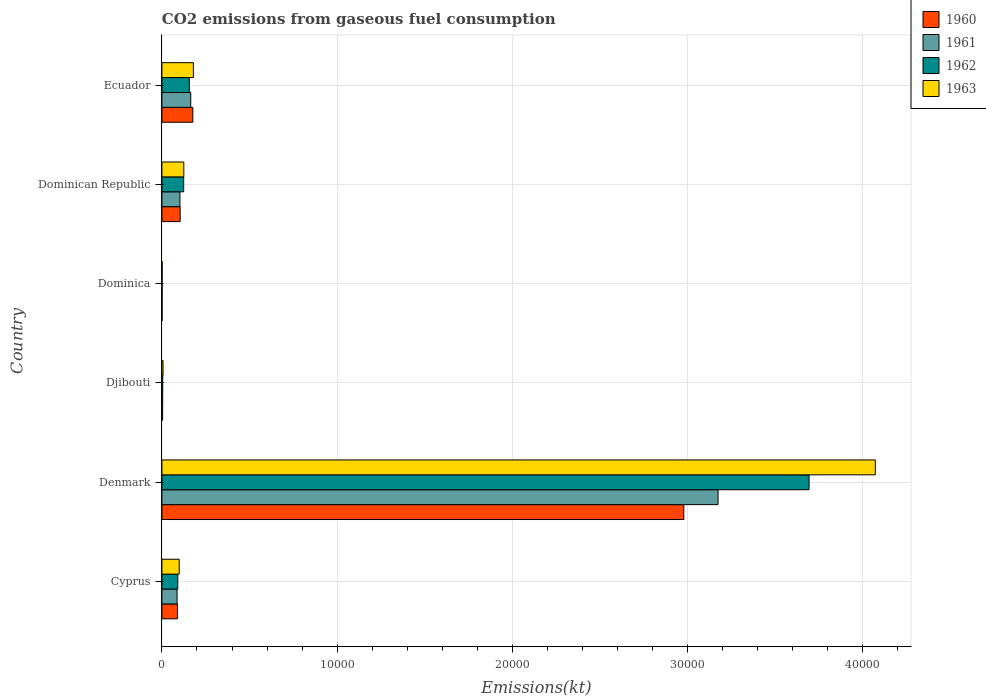How many different coloured bars are there?
Offer a very short reply. 4. How many groups of bars are there?
Keep it short and to the point. 6. Are the number of bars per tick equal to the number of legend labels?
Your response must be concise. Yes. How many bars are there on the 2nd tick from the top?
Give a very brief answer. 4. What is the label of the 4th group of bars from the top?
Keep it short and to the point. Djibouti. In how many cases, is the number of bars for a given country not equal to the number of legend labels?
Give a very brief answer. 0. What is the amount of CO2 emitted in 1961 in Denmark?
Give a very brief answer. 3.17e+04. Across all countries, what is the maximum amount of CO2 emitted in 1961?
Your answer should be very brief. 3.17e+04. Across all countries, what is the minimum amount of CO2 emitted in 1960?
Make the answer very short. 11. In which country was the amount of CO2 emitted in 1963 minimum?
Keep it short and to the point. Dominica. What is the total amount of CO2 emitted in 1961 in the graph?
Give a very brief answer. 3.53e+04. What is the difference between the amount of CO2 emitted in 1963 in Djibouti and that in Dominican Republic?
Give a very brief answer. -1184.44. What is the difference between the amount of CO2 emitted in 1960 in Cyprus and the amount of CO2 emitted in 1963 in Denmark?
Make the answer very short. -3.98e+04. What is the average amount of CO2 emitted in 1960 per country?
Give a very brief answer. 5587.29. What is the difference between the amount of CO2 emitted in 1962 and amount of CO2 emitted in 1961 in Dominica?
Provide a succinct answer. 0. What is the ratio of the amount of CO2 emitted in 1962 in Denmark to that in Ecuador?
Give a very brief answer. 23.58. Is the amount of CO2 emitted in 1962 in Cyprus less than that in Denmark?
Your answer should be compact. Yes. What is the difference between the highest and the second highest amount of CO2 emitted in 1962?
Provide a succinct answer. 3.54e+04. What is the difference between the highest and the lowest amount of CO2 emitted in 1962?
Give a very brief answer. 3.69e+04. In how many countries, is the amount of CO2 emitted in 1961 greater than the average amount of CO2 emitted in 1961 taken over all countries?
Provide a short and direct response. 1. Is it the case that in every country, the sum of the amount of CO2 emitted in 1960 and amount of CO2 emitted in 1961 is greater than the amount of CO2 emitted in 1963?
Give a very brief answer. Yes. How many bars are there?
Provide a short and direct response. 24. Are the values on the major ticks of X-axis written in scientific E-notation?
Keep it short and to the point. No. How many legend labels are there?
Give a very brief answer. 4. How are the legend labels stacked?
Offer a terse response. Vertical. What is the title of the graph?
Ensure brevity in your answer.  CO2 emissions from gaseous fuel consumption. Does "1998" appear as one of the legend labels in the graph?
Offer a terse response. No. What is the label or title of the X-axis?
Provide a short and direct response. Emissions(kt). What is the Emissions(kt) of 1960 in Cyprus?
Your answer should be compact. 887.41. What is the Emissions(kt) of 1961 in Cyprus?
Offer a terse response. 865.41. What is the Emissions(kt) of 1962 in Cyprus?
Provide a succinct answer. 905.75. What is the Emissions(kt) of 1963 in Cyprus?
Provide a succinct answer. 986.42. What is the Emissions(kt) of 1960 in Denmark?
Make the answer very short. 2.98e+04. What is the Emissions(kt) in 1961 in Denmark?
Provide a succinct answer. 3.17e+04. What is the Emissions(kt) in 1962 in Denmark?
Make the answer very short. 3.69e+04. What is the Emissions(kt) in 1963 in Denmark?
Make the answer very short. 4.07e+04. What is the Emissions(kt) of 1960 in Djibouti?
Give a very brief answer. 40.34. What is the Emissions(kt) of 1961 in Djibouti?
Make the answer very short. 44. What is the Emissions(kt) of 1962 in Djibouti?
Ensure brevity in your answer.  47.67. What is the Emissions(kt) in 1963 in Djibouti?
Your answer should be very brief. 66.01. What is the Emissions(kt) of 1960 in Dominica?
Your answer should be very brief. 11. What is the Emissions(kt) of 1961 in Dominica?
Provide a short and direct response. 11. What is the Emissions(kt) in 1962 in Dominica?
Your answer should be compact. 11. What is the Emissions(kt) of 1963 in Dominica?
Ensure brevity in your answer.  14.67. What is the Emissions(kt) of 1960 in Dominican Republic?
Your answer should be very brief. 1041.43. What is the Emissions(kt) of 1961 in Dominican Republic?
Offer a terse response. 1030.43. What is the Emissions(kt) in 1962 in Dominican Republic?
Ensure brevity in your answer.  1243.11. What is the Emissions(kt) of 1963 in Dominican Republic?
Your answer should be very brief. 1250.45. What is the Emissions(kt) of 1960 in Ecuador?
Provide a short and direct response. 1763.83. What is the Emissions(kt) in 1961 in Ecuador?
Your response must be concise. 1646.48. What is the Emissions(kt) in 1962 in Ecuador?
Offer a terse response. 1565.81. What is the Emissions(kt) of 1963 in Ecuador?
Ensure brevity in your answer.  1796.83. Across all countries, what is the maximum Emissions(kt) in 1960?
Your response must be concise. 2.98e+04. Across all countries, what is the maximum Emissions(kt) of 1961?
Make the answer very short. 3.17e+04. Across all countries, what is the maximum Emissions(kt) in 1962?
Ensure brevity in your answer.  3.69e+04. Across all countries, what is the maximum Emissions(kt) of 1963?
Your answer should be compact. 4.07e+04. Across all countries, what is the minimum Emissions(kt) of 1960?
Give a very brief answer. 11. Across all countries, what is the minimum Emissions(kt) in 1961?
Offer a very short reply. 11. Across all countries, what is the minimum Emissions(kt) of 1962?
Your response must be concise. 11. Across all countries, what is the minimum Emissions(kt) of 1963?
Your response must be concise. 14.67. What is the total Emissions(kt) of 1960 in the graph?
Ensure brevity in your answer.  3.35e+04. What is the total Emissions(kt) in 1961 in the graph?
Provide a succinct answer. 3.53e+04. What is the total Emissions(kt) of 1962 in the graph?
Your answer should be compact. 4.07e+04. What is the total Emissions(kt) in 1963 in the graph?
Offer a very short reply. 4.48e+04. What is the difference between the Emissions(kt) of 1960 in Cyprus and that in Denmark?
Your answer should be very brief. -2.89e+04. What is the difference between the Emissions(kt) of 1961 in Cyprus and that in Denmark?
Give a very brief answer. -3.09e+04. What is the difference between the Emissions(kt) in 1962 in Cyprus and that in Denmark?
Ensure brevity in your answer.  -3.60e+04. What is the difference between the Emissions(kt) of 1963 in Cyprus and that in Denmark?
Offer a very short reply. -3.97e+04. What is the difference between the Emissions(kt) of 1960 in Cyprus and that in Djibouti?
Offer a very short reply. 847.08. What is the difference between the Emissions(kt) of 1961 in Cyprus and that in Djibouti?
Offer a terse response. 821.41. What is the difference between the Emissions(kt) in 1962 in Cyprus and that in Djibouti?
Your answer should be very brief. 858.08. What is the difference between the Emissions(kt) of 1963 in Cyprus and that in Djibouti?
Your response must be concise. 920.42. What is the difference between the Emissions(kt) of 1960 in Cyprus and that in Dominica?
Your response must be concise. 876.41. What is the difference between the Emissions(kt) of 1961 in Cyprus and that in Dominica?
Offer a very short reply. 854.41. What is the difference between the Emissions(kt) in 1962 in Cyprus and that in Dominica?
Provide a succinct answer. 894.75. What is the difference between the Emissions(kt) in 1963 in Cyprus and that in Dominica?
Provide a short and direct response. 971.75. What is the difference between the Emissions(kt) of 1960 in Cyprus and that in Dominican Republic?
Your answer should be very brief. -154.01. What is the difference between the Emissions(kt) of 1961 in Cyprus and that in Dominican Republic?
Keep it short and to the point. -165.01. What is the difference between the Emissions(kt) in 1962 in Cyprus and that in Dominican Republic?
Provide a succinct answer. -337.36. What is the difference between the Emissions(kt) in 1963 in Cyprus and that in Dominican Republic?
Offer a terse response. -264.02. What is the difference between the Emissions(kt) of 1960 in Cyprus and that in Ecuador?
Give a very brief answer. -876.41. What is the difference between the Emissions(kt) of 1961 in Cyprus and that in Ecuador?
Keep it short and to the point. -781.07. What is the difference between the Emissions(kt) of 1962 in Cyprus and that in Ecuador?
Keep it short and to the point. -660.06. What is the difference between the Emissions(kt) of 1963 in Cyprus and that in Ecuador?
Ensure brevity in your answer.  -810.41. What is the difference between the Emissions(kt) in 1960 in Denmark and that in Djibouti?
Your answer should be very brief. 2.97e+04. What is the difference between the Emissions(kt) of 1961 in Denmark and that in Djibouti?
Offer a very short reply. 3.17e+04. What is the difference between the Emissions(kt) of 1962 in Denmark and that in Djibouti?
Keep it short and to the point. 3.69e+04. What is the difference between the Emissions(kt) in 1963 in Denmark and that in Djibouti?
Make the answer very short. 4.06e+04. What is the difference between the Emissions(kt) in 1960 in Denmark and that in Dominica?
Offer a very short reply. 2.98e+04. What is the difference between the Emissions(kt) of 1961 in Denmark and that in Dominica?
Ensure brevity in your answer.  3.17e+04. What is the difference between the Emissions(kt) in 1962 in Denmark and that in Dominica?
Offer a terse response. 3.69e+04. What is the difference between the Emissions(kt) in 1963 in Denmark and that in Dominica?
Ensure brevity in your answer.  4.07e+04. What is the difference between the Emissions(kt) in 1960 in Denmark and that in Dominican Republic?
Your response must be concise. 2.87e+04. What is the difference between the Emissions(kt) in 1961 in Denmark and that in Dominican Republic?
Your answer should be compact. 3.07e+04. What is the difference between the Emissions(kt) in 1962 in Denmark and that in Dominican Republic?
Your answer should be compact. 3.57e+04. What is the difference between the Emissions(kt) of 1963 in Denmark and that in Dominican Republic?
Provide a short and direct response. 3.95e+04. What is the difference between the Emissions(kt) of 1960 in Denmark and that in Ecuador?
Ensure brevity in your answer.  2.80e+04. What is the difference between the Emissions(kt) of 1961 in Denmark and that in Ecuador?
Your response must be concise. 3.01e+04. What is the difference between the Emissions(kt) in 1962 in Denmark and that in Ecuador?
Ensure brevity in your answer.  3.54e+04. What is the difference between the Emissions(kt) of 1963 in Denmark and that in Ecuador?
Offer a terse response. 3.89e+04. What is the difference between the Emissions(kt) of 1960 in Djibouti and that in Dominica?
Give a very brief answer. 29.34. What is the difference between the Emissions(kt) in 1961 in Djibouti and that in Dominica?
Your response must be concise. 33. What is the difference between the Emissions(kt) in 1962 in Djibouti and that in Dominica?
Keep it short and to the point. 36.67. What is the difference between the Emissions(kt) in 1963 in Djibouti and that in Dominica?
Provide a short and direct response. 51.34. What is the difference between the Emissions(kt) of 1960 in Djibouti and that in Dominican Republic?
Offer a very short reply. -1001.09. What is the difference between the Emissions(kt) of 1961 in Djibouti and that in Dominican Republic?
Give a very brief answer. -986.42. What is the difference between the Emissions(kt) of 1962 in Djibouti and that in Dominican Republic?
Ensure brevity in your answer.  -1195.44. What is the difference between the Emissions(kt) of 1963 in Djibouti and that in Dominican Republic?
Make the answer very short. -1184.44. What is the difference between the Emissions(kt) in 1960 in Djibouti and that in Ecuador?
Offer a very short reply. -1723.49. What is the difference between the Emissions(kt) in 1961 in Djibouti and that in Ecuador?
Make the answer very short. -1602.48. What is the difference between the Emissions(kt) in 1962 in Djibouti and that in Ecuador?
Provide a short and direct response. -1518.14. What is the difference between the Emissions(kt) in 1963 in Djibouti and that in Ecuador?
Your answer should be very brief. -1730.82. What is the difference between the Emissions(kt) of 1960 in Dominica and that in Dominican Republic?
Provide a succinct answer. -1030.43. What is the difference between the Emissions(kt) of 1961 in Dominica and that in Dominican Republic?
Offer a very short reply. -1019.43. What is the difference between the Emissions(kt) in 1962 in Dominica and that in Dominican Republic?
Your answer should be very brief. -1232.11. What is the difference between the Emissions(kt) of 1963 in Dominica and that in Dominican Republic?
Offer a terse response. -1235.78. What is the difference between the Emissions(kt) in 1960 in Dominica and that in Ecuador?
Ensure brevity in your answer.  -1752.83. What is the difference between the Emissions(kt) of 1961 in Dominica and that in Ecuador?
Make the answer very short. -1635.48. What is the difference between the Emissions(kt) of 1962 in Dominica and that in Ecuador?
Your response must be concise. -1554.81. What is the difference between the Emissions(kt) in 1963 in Dominica and that in Ecuador?
Give a very brief answer. -1782.16. What is the difference between the Emissions(kt) in 1960 in Dominican Republic and that in Ecuador?
Provide a short and direct response. -722.4. What is the difference between the Emissions(kt) in 1961 in Dominican Republic and that in Ecuador?
Provide a short and direct response. -616.06. What is the difference between the Emissions(kt) in 1962 in Dominican Republic and that in Ecuador?
Provide a short and direct response. -322.7. What is the difference between the Emissions(kt) of 1963 in Dominican Republic and that in Ecuador?
Offer a very short reply. -546.38. What is the difference between the Emissions(kt) of 1960 in Cyprus and the Emissions(kt) of 1961 in Denmark?
Offer a terse response. -3.08e+04. What is the difference between the Emissions(kt) in 1960 in Cyprus and the Emissions(kt) in 1962 in Denmark?
Keep it short and to the point. -3.60e+04. What is the difference between the Emissions(kt) in 1960 in Cyprus and the Emissions(kt) in 1963 in Denmark?
Provide a short and direct response. -3.98e+04. What is the difference between the Emissions(kt) in 1961 in Cyprus and the Emissions(kt) in 1962 in Denmark?
Your answer should be compact. -3.61e+04. What is the difference between the Emissions(kt) in 1961 in Cyprus and the Emissions(kt) in 1963 in Denmark?
Your response must be concise. -3.98e+04. What is the difference between the Emissions(kt) of 1962 in Cyprus and the Emissions(kt) of 1963 in Denmark?
Offer a very short reply. -3.98e+04. What is the difference between the Emissions(kt) of 1960 in Cyprus and the Emissions(kt) of 1961 in Djibouti?
Provide a succinct answer. 843.41. What is the difference between the Emissions(kt) of 1960 in Cyprus and the Emissions(kt) of 1962 in Djibouti?
Make the answer very short. 839.74. What is the difference between the Emissions(kt) in 1960 in Cyprus and the Emissions(kt) in 1963 in Djibouti?
Your response must be concise. 821.41. What is the difference between the Emissions(kt) of 1961 in Cyprus and the Emissions(kt) of 1962 in Djibouti?
Your answer should be very brief. 817.74. What is the difference between the Emissions(kt) in 1961 in Cyprus and the Emissions(kt) in 1963 in Djibouti?
Ensure brevity in your answer.  799.41. What is the difference between the Emissions(kt) of 1962 in Cyprus and the Emissions(kt) of 1963 in Djibouti?
Make the answer very short. 839.74. What is the difference between the Emissions(kt) of 1960 in Cyprus and the Emissions(kt) of 1961 in Dominica?
Keep it short and to the point. 876.41. What is the difference between the Emissions(kt) of 1960 in Cyprus and the Emissions(kt) of 1962 in Dominica?
Give a very brief answer. 876.41. What is the difference between the Emissions(kt) of 1960 in Cyprus and the Emissions(kt) of 1963 in Dominica?
Ensure brevity in your answer.  872.75. What is the difference between the Emissions(kt) in 1961 in Cyprus and the Emissions(kt) in 1962 in Dominica?
Offer a terse response. 854.41. What is the difference between the Emissions(kt) of 1961 in Cyprus and the Emissions(kt) of 1963 in Dominica?
Ensure brevity in your answer.  850.74. What is the difference between the Emissions(kt) in 1962 in Cyprus and the Emissions(kt) in 1963 in Dominica?
Provide a short and direct response. 891.08. What is the difference between the Emissions(kt) of 1960 in Cyprus and the Emissions(kt) of 1961 in Dominican Republic?
Your answer should be compact. -143.01. What is the difference between the Emissions(kt) of 1960 in Cyprus and the Emissions(kt) of 1962 in Dominican Republic?
Provide a short and direct response. -355.7. What is the difference between the Emissions(kt) in 1960 in Cyprus and the Emissions(kt) in 1963 in Dominican Republic?
Ensure brevity in your answer.  -363.03. What is the difference between the Emissions(kt) of 1961 in Cyprus and the Emissions(kt) of 1962 in Dominican Republic?
Your response must be concise. -377.7. What is the difference between the Emissions(kt) of 1961 in Cyprus and the Emissions(kt) of 1963 in Dominican Republic?
Provide a short and direct response. -385.04. What is the difference between the Emissions(kt) of 1962 in Cyprus and the Emissions(kt) of 1963 in Dominican Republic?
Give a very brief answer. -344.7. What is the difference between the Emissions(kt) in 1960 in Cyprus and the Emissions(kt) in 1961 in Ecuador?
Your answer should be compact. -759.07. What is the difference between the Emissions(kt) in 1960 in Cyprus and the Emissions(kt) in 1962 in Ecuador?
Keep it short and to the point. -678.39. What is the difference between the Emissions(kt) of 1960 in Cyprus and the Emissions(kt) of 1963 in Ecuador?
Provide a short and direct response. -909.42. What is the difference between the Emissions(kt) in 1961 in Cyprus and the Emissions(kt) in 1962 in Ecuador?
Ensure brevity in your answer.  -700.4. What is the difference between the Emissions(kt) in 1961 in Cyprus and the Emissions(kt) in 1963 in Ecuador?
Your answer should be compact. -931.42. What is the difference between the Emissions(kt) of 1962 in Cyprus and the Emissions(kt) of 1963 in Ecuador?
Provide a short and direct response. -891.08. What is the difference between the Emissions(kt) in 1960 in Denmark and the Emissions(kt) in 1961 in Djibouti?
Your answer should be compact. 2.97e+04. What is the difference between the Emissions(kt) in 1960 in Denmark and the Emissions(kt) in 1962 in Djibouti?
Your answer should be compact. 2.97e+04. What is the difference between the Emissions(kt) of 1960 in Denmark and the Emissions(kt) of 1963 in Djibouti?
Give a very brief answer. 2.97e+04. What is the difference between the Emissions(kt) in 1961 in Denmark and the Emissions(kt) in 1962 in Djibouti?
Keep it short and to the point. 3.17e+04. What is the difference between the Emissions(kt) in 1961 in Denmark and the Emissions(kt) in 1963 in Djibouti?
Your answer should be very brief. 3.17e+04. What is the difference between the Emissions(kt) in 1962 in Denmark and the Emissions(kt) in 1963 in Djibouti?
Keep it short and to the point. 3.69e+04. What is the difference between the Emissions(kt) in 1960 in Denmark and the Emissions(kt) in 1961 in Dominica?
Give a very brief answer. 2.98e+04. What is the difference between the Emissions(kt) of 1960 in Denmark and the Emissions(kt) of 1962 in Dominica?
Give a very brief answer. 2.98e+04. What is the difference between the Emissions(kt) of 1960 in Denmark and the Emissions(kt) of 1963 in Dominica?
Give a very brief answer. 2.98e+04. What is the difference between the Emissions(kt) of 1961 in Denmark and the Emissions(kt) of 1962 in Dominica?
Provide a succinct answer. 3.17e+04. What is the difference between the Emissions(kt) of 1961 in Denmark and the Emissions(kt) of 1963 in Dominica?
Keep it short and to the point. 3.17e+04. What is the difference between the Emissions(kt) of 1962 in Denmark and the Emissions(kt) of 1963 in Dominica?
Offer a very short reply. 3.69e+04. What is the difference between the Emissions(kt) in 1960 in Denmark and the Emissions(kt) in 1961 in Dominican Republic?
Provide a succinct answer. 2.87e+04. What is the difference between the Emissions(kt) in 1960 in Denmark and the Emissions(kt) in 1962 in Dominican Republic?
Give a very brief answer. 2.85e+04. What is the difference between the Emissions(kt) in 1960 in Denmark and the Emissions(kt) in 1963 in Dominican Republic?
Offer a terse response. 2.85e+04. What is the difference between the Emissions(kt) in 1961 in Denmark and the Emissions(kt) in 1962 in Dominican Republic?
Your answer should be compact. 3.05e+04. What is the difference between the Emissions(kt) in 1961 in Denmark and the Emissions(kt) in 1963 in Dominican Republic?
Offer a very short reply. 3.05e+04. What is the difference between the Emissions(kt) of 1962 in Denmark and the Emissions(kt) of 1963 in Dominican Republic?
Offer a very short reply. 3.57e+04. What is the difference between the Emissions(kt) in 1960 in Denmark and the Emissions(kt) in 1961 in Ecuador?
Your response must be concise. 2.81e+04. What is the difference between the Emissions(kt) in 1960 in Denmark and the Emissions(kt) in 1962 in Ecuador?
Provide a short and direct response. 2.82e+04. What is the difference between the Emissions(kt) of 1960 in Denmark and the Emissions(kt) of 1963 in Ecuador?
Your answer should be compact. 2.80e+04. What is the difference between the Emissions(kt) of 1961 in Denmark and the Emissions(kt) of 1962 in Ecuador?
Give a very brief answer. 3.02e+04. What is the difference between the Emissions(kt) of 1961 in Denmark and the Emissions(kt) of 1963 in Ecuador?
Ensure brevity in your answer.  2.99e+04. What is the difference between the Emissions(kt) of 1962 in Denmark and the Emissions(kt) of 1963 in Ecuador?
Provide a succinct answer. 3.51e+04. What is the difference between the Emissions(kt) in 1960 in Djibouti and the Emissions(kt) in 1961 in Dominica?
Provide a succinct answer. 29.34. What is the difference between the Emissions(kt) of 1960 in Djibouti and the Emissions(kt) of 1962 in Dominica?
Offer a very short reply. 29.34. What is the difference between the Emissions(kt) in 1960 in Djibouti and the Emissions(kt) in 1963 in Dominica?
Your answer should be very brief. 25.67. What is the difference between the Emissions(kt) in 1961 in Djibouti and the Emissions(kt) in 1962 in Dominica?
Offer a very short reply. 33. What is the difference between the Emissions(kt) of 1961 in Djibouti and the Emissions(kt) of 1963 in Dominica?
Your response must be concise. 29.34. What is the difference between the Emissions(kt) of 1962 in Djibouti and the Emissions(kt) of 1963 in Dominica?
Give a very brief answer. 33. What is the difference between the Emissions(kt) in 1960 in Djibouti and the Emissions(kt) in 1961 in Dominican Republic?
Provide a succinct answer. -990.09. What is the difference between the Emissions(kt) in 1960 in Djibouti and the Emissions(kt) in 1962 in Dominican Republic?
Provide a short and direct response. -1202.78. What is the difference between the Emissions(kt) in 1960 in Djibouti and the Emissions(kt) in 1963 in Dominican Republic?
Provide a short and direct response. -1210.11. What is the difference between the Emissions(kt) in 1961 in Djibouti and the Emissions(kt) in 1962 in Dominican Republic?
Offer a terse response. -1199.11. What is the difference between the Emissions(kt) in 1961 in Djibouti and the Emissions(kt) in 1963 in Dominican Republic?
Your answer should be very brief. -1206.44. What is the difference between the Emissions(kt) in 1962 in Djibouti and the Emissions(kt) in 1963 in Dominican Republic?
Ensure brevity in your answer.  -1202.78. What is the difference between the Emissions(kt) of 1960 in Djibouti and the Emissions(kt) of 1961 in Ecuador?
Your response must be concise. -1606.15. What is the difference between the Emissions(kt) in 1960 in Djibouti and the Emissions(kt) in 1962 in Ecuador?
Keep it short and to the point. -1525.47. What is the difference between the Emissions(kt) of 1960 in Djibouti and the Emissions(kt) of 1963 in Ecuador?
Your response must be concise. -1756.49. What is the difference between the Emissions(kt) of 1961 in Djibouti and the Emissions(kt) of 1962 in Ecuador?
Offer a very short reply. -1521.81. What is the difference between the Emissions(kt) of 1961 in Djibouti and the Emissions(kt) of 1963 in Ecuador?
Ensure brevity in your answer.  -1752.83. What is the difference between the Emissions(kt) in 1962 in Djibouti and the Emissions(kt) in 1963 in Ecuador?
Make the answer very short. -1749.16. What is the difference between the Emissions(kt) in 1960 in Dominica and the Emissions(kt) in 1961 in Dominican Republic?
Keep it short and to the point. -1019.43. What is the difference between the Emissions(kt) of 1960 in Dominica and the Emissions(kt) of 1962 in Dominican Republic?
Your response must be concise. -1232.11. What is the difference between the Emissions(kt) of 1960 in Dominica and the Emissions(kt) of 1963 in Dominican Republic?
Offer a terse response. -1239.45. What is the difference between the Emissions(kt) in 1961 in Dominica and the Emissions(kt) in 1962 in Dominican Republic?
Offer a terse response. -1232.11. What is the difference between the Emissions(kt) of 1961 in Dominica and the Emissions(kt) of 1963 in Dominican Republic?
Your answer should be compact. -1239.45. What is the difference between the Emissions(kt) in 1962 in Dominica and the Emissions(kt) in 1963 in Dominican Republic?
Your response must be concise. -1239.45. What is the difference between the Emissions(kt) in 1960 in Dominica and the Emissions(kt) in 1961 in Ecuador?
Your response must be concise. -1635.48. What is the difference between the Emissions(kt) of 1960 in Dominica and the Emissions(kt) of 1962 in Ecuador?
Keep it short and to the point. -1554.81. What is the difference between the Emissions(kt) in 1960 in Dominica and the Emissions(kt) in 1963 in Ecuador?
Make the answer very short. -1785.83. What is the difference between the Emissions(kt) in 1961 in Dominica and the Emissions(kt) in 1962 in Ecuador?
Your answer should be very brief. -1554.81. What is the difference between the Emissions(kt) in 1961 in Dominica and the Emissions(kt) in 1963 in Ecuador?
Offer a terse response. -1785.83. What is the difference between the Emissions(kt) in 1962 in Dominica and the Emissions(kt) in 1963 in Ecuador?
Give a very brief answer. -1785.83. What is the difference between the Emissions(kt) in 1960 in Dominican Republic and the Emissions(kt) in 1961 in Ecuador?
Your answer should be compact. -605.05. What is the difference between the Emissions(kt) in 1960 in Dominican Republic and the Emissions(kt) in 1962 in Ecuador?
Provide a succinct answer. -524.38. What is the difference between the Emissions(kt) in 1960 in Dominican Republic and the Emissions(kt) in 1963 in Ecuador?
Your response must be concise. -755.4. What is the difference between the Emissions(kt) in 1961 in Dominican Republic and the Emissions(kt) in 1962 in Ecuador?
Your answer should be very brief. -535.38. What is the difference between the Emissions(kt) of 1961 in Dominican Republic and the Emissions(kt) of 1963 in Ecuador?
Provide a succinct answer. -766.4. What is the difference between the Emissions(kt) of 1962 in Dominican Republic and the Emissions(kt) of 1963 in Ecuador?
Your answer should be compact. -553.72. What is the average Emissions(kt) of 1960 per country?
Make the answer very short. 5587.29. What is the average Emissions(kt) of 1961 per country?
Your answer should be compact. 5888.59. What is the average Emissions(kt) of 1962 per country?
Ensure brevity in your answer.  6783.34. What is the average Emissions(kt) in 1963 per country?
Provide a succinct answer. 7470.29. What is the difference between the Emissions(kt) of 1960 and Emissions(kt) of 1961 in Cyprus?
Your response must be concise. 22. What is the difference between the Emissions(kt) of 1960 and Emissions(kt) of 1962 in Cyprus?
Offer a very short reply. -18.34. What is the difference between the Emissions(kt) in 1960 and Emissions(kt) in 1963 in Cyprus?
Give a very brief answer. -99.01. What is the difference between the Emissions(kt) in 1961 and Emissions(kt) in 1962 in Cyprus?
Keep it short and to the point. -40.34. What is the difference between the Emissions(kt) of 1961 and Emissions(kt) of 1963 in Cyprus?
Your answer should be very brief. -121.01. What is the difference between the Emissions(kt) in 1962 and Emissions(kt) in 1963 in Cyprus?
Give a very brief answer. -80.67. What is the difference between the Emissions(kt) in 1960 and Emissions(kt) in 1961 in Denmark?
Ensure brevity in your answer.  -1954.51. What is the difference between the Emissions(kt) in 1960 and Emissions(kt) in 1962 in Denmark?
Your answer should be very brief. -7146.98. What is the difference between the Emissions(kt) of 1960 and Emissions(kt) of 1963 in Denmark?
Make the answer very short. -1.09e+04. What is the difference between the Emissions(kt) in 1961 and Emissions(kt) in 1962 in Denmark?
Your answer should be compact. -5192.47. What is the difference between the Emissions(kt) of 1961 and Emissions(kt) of 1963 in Denmark?
Provide a short and direct response. -8973.15. What is the difference between the Emissions(kt) in 1962 and Emissions(kt) in 1963 in Denmark?
Ensure brevity in your answer.  -3780.68. What is the difference between the Emissions(kt) in 1960 and Emissions(kt) in 1961 in Djibouti?
Give a very brief answer. -3.67. What is the difference between the Emissions(kt) in 1960 and Emissions(kt) in 1962 in Djibouti?
Ensure brevity in your answer.  -7.33. What is the difference between the Emissions(kt) in 1960 and Emissions(kt) in 1963 in Djibouti?
Your answer should be very brief. -25.67. What is the difference between the Emissions(kt) of 1961 and Emissions(kt) of 1962 in Djibouti?
Your response must be concise. -3.67. What is the difference between the Emissions(kt) in 1961 and Emissions(kt) in 1963 in Djibouti?
Your answer should be compact. -22. What is the difference between the Emissions(kt) of 1962 and Emissions(kt) of 1963 in Djibouti?
Offer a very short reply. -18.34. What is the difference between the Emissions(kt) in 1960 and Emissions(kt) in 1962 in Dominica?
Offer a very short reply. 0. What is the difference between the Emissions(kt) in 1960 and Emissions(kt) in 1963 in Dominica?
Your answer should be very brief. -3.67. What is the difference between the Emissions(kt) in 1961 and Emissions(kt) in 1962 in Dominica?
Offer a very short reply. 0. What is the difference between the Emissions(kt) of 1961 and Emissions(kt) of 1963 in Dominica?
Provide a short and direct response. -3.67. What is the difference between the Emissions(kt) in 1962 and Emissions(kt) in 1963 in Dominica?
Make the answer very short. -3.67. What is the difference between the Emissions(kt) in 1960 and Emissions(kt) in 1961 in Dominican Republic?
Give a very brief answer. 11. What is the difference between the Emissions(kt) of 1960 and Emissions(kt) of 1962 in Dominican Republic?
Your answer should be compact. -201.69. What is the difference between the Emissions(kt) in 1960 and Emissions(kt) in 1963 in Dominican Republic?
Your answer should be very brief. -209.02. What is the difference between the Emissions(kt) of 1961 and Emissions(kt) of 1962 in Dominican Republic?
Make the answer very short. -212.69. What is the difference between the Emissions(kt) of 1961 and Emissions(kt) of 1963 in Dominican Republic?
Ensure brevity in your answer.  -220.02. What is the difference between the Emissions(kt) of 1962 and Emissions(kt) of 1963 in Dominican Republic?
Your answer should be very brief. -7.33. What is the difference between the Emissions(kt) in 1960 and Emissions(kt) in 1961 in Ecuador?
Your answer should be compact. 117.34. What is the difference between the Emissions(kt) of 1960 and Emissions(kt) of 1962 in Ecuador?
Offer a terse response. 198.02. What is the difference between the Emissions(kt) of 1960 and Emissions(kt) of 1963 in Ecuador?
Offer a terse response. -33. What is the difference between the Emissions(kt) in 1961 and Emissions(kt) in 1962 in Ecuador?
Your answer should be very brief. 80.67. What is the difference between the Emissions(kt) in 1961 and Emissions(kt) in 1963 in Ecuador?
Offer a terse response. -150.35. What is the difference between the Emissions(kt) in 1962 and Emissions(kt) in 1963 in Ecuador?
Your answer should be very brief. -231.02. What is the ratio of the Emissions(kt) in 1960 in Cyprus to that in Denmark?
Provide a succinct answer. 0.03. What is the ratio of the Emissions(kt) of 1961 in Cyprus to that in Denmark?
Provide a short and direct response. 0.03. What is the ratio of the Emissions(kt) of 1962 in Cyprus to that in Denmark?
Your answer should be very brief. 0.02. What is the ratio of the Emissions(kt) in 1963 in Cyprus to that in Denmark?
Offer a very short reply. 0.02. What is the ratio of the Emissions(kt) of 1960 in Cyprus to that in Djibouti?
Ensure brevity in your answer.  22. What is the ratio of the Emissions(kt) of 1961 in Cyprus to that in Djibouti?
Offer a very short reply. 19.67. What is the ratio of the Emissions(kt) in 1963 in Cyprus to that in Djibouti?
Your answer should be very brief. 14.94. What is the ratio of the Emissions(kt) in 1960 in Cyprus to that in Dominica?
Offer a terse response. 80.67. What is the ratio of the Emissions(kt) in 1961 in Cyprus to that in Dominica?
Give a very brief answer. 78.67. What is the ratio of the Emissions(kt) of 1962 in Cyprus to that in Dominica?
Your answer should be very brief. 82.33. What is the ratio of the Emissions(kt) in 1963 in Cyprus to that in Dominica?
Provide a short and direct response. 67.25. What is the ratio of the Emissions(kt) of 1960 in Cyprus to that in Dominican Republic?
Your answer should be compact. 0.85. What is the ratio of the Emissions(kt) in 1961 in Cyprus to that in Dominican Republic?
Provide a succinct answer. 0.84. What is the ratio of the Emissions(kt) in 1962 in Cyprus to that in Dominican Republic?
Offer a very short reply. 0.73. What is the ratio of the Emissions(kt) of 1963 in Cyprus to that in Dominican Republic?
Offer a terse response. 0.79. What is the ratio of the Emissions(kt) in 1960 in Cyprus to that in Ecuador?
Ensure brevity in your answer.  0.5. What is the ratio of the Emissions(kt) of 1961 in Cyprus to that in Ecuador?
Give a very brief answer. 0.53. What is the ratio of the Emissions(kt) in 1962 in Cyprus to that in Ecuador?
Keep it short and to the point. 0.58. What is the ratio of the Emissions(kt) in 1963 in Cyprus to that in Ecuador?
Your answer should be very brief. 0.55. What is the ratio of the Emissions(kt) in 1960 in Denmark to that in Djibouti?
Your answer should be very brief. 738.27. What is the ratio of the Emissions(kt) of 1961 in Denmark to that in Djibouti?
Provide a succinct answer. 721.17. What is the ratio of the Emissions(kt) in 1962 in Denmark to that in Djibouti?
Ensure brevity in your answer.  774.62. What is the ratio of the Emissions(kt) in 1963 in Denmark to that in Djibouti?
Ensure brevity in your answer.  616.72. What is the ratio of the Emissions(kt) of 1960 in Denmark to that in Dominica?
Your response must be concise. 2707. What is the ratio of the Emissions(kt) of 1961 in Denmark to that in Dominica?
Provide a succinct answer. 2884.67. What is the ratio of the Emissions(kt) in 1962 in Denmark to that in Dominica?
Offer a terse response. 3356.67. What is the ratio of the Emissions(kt) of 1963 in Denmark to that in Dominica?
Provide a short and direct response. 2775.25. What is the ratio of the Emissions(kt) of 1960 in Denmark to that in Dominican Republic?
Offer a terse response. 28.6. What is the ratio of the Emissions(kt) in 1961 in Denmark to that in Dominican Republic?
Provide a succinct answer. 30.8. What is the ratio of the Emissions(kt) in 1962 in Denmark to that in Dominican Republic?
Provide a succinct answer. 29.7. What is the ratio of the Emissions(kt) in 1963 in Denmark to that in Dominican Republic?
Make the answer very short. 32.55. What is the ratio of the Emissions(kt) of 1960 in Denmark to that in Ecuador?
Keep it short and to the point. 16.88. What is the ratio of the Emissions(kt) in 1961 in Denmark to that in Ecuador?
Your answer should be very brief. 19.27. What is the ratio of the Emissions(kt) of 1962 in Denmark to that in Ecuador?
Provide a short and direct response. 23.58. What is the ratio of the Emissions(kt) of 1963 in Denmark to that in Ecuador?
Provide a short and direct response. 22.66. What is the ratio of the Emissions(kt) of 1960 in Djibouti to that in Dominica?
Your response must be concise. 3.67. What is the ratio of the Emissions(kt) of 1962 in Djibouti to that in Dominica?
Offer a very short reply. 4.33. What is the ratio of the Emissions(kt) in 1960 in Djibouti to that in Dominican Republic?
Provide a succinct answer. 0.04. What is the ratio of the Emissions(kt) of 1961 in Djibouti to that in Dominican Republic?
Your response must be concise. 0.04. What is the ratio of the Emissions(kt) in 1962 in Djibouti to that in Dominican Republic?
Ensure brevity in your answer.  0.04. What is the ratio of the Emissions(kt) of 1963 in Djibouti to that in Dominican Republic?
Provide a short and direct response. 0.05. What is the ratio of the Emissions(kt) in 1960 in Djibouti to that in Ecuador?
Ensure brevity in your answer.  0.02. What is the ratio of the Emissions(kt) in 1961 in Djibouti to that in Ecuador?
Offer a terse response. 0.03. What is the ratio of the Emissions(kt) in 1962 in Djibouti to that in Ecuador?
Give a very brief answer. 0.03. What is the ratio of the Emissions(kt) in 1963 in Djibouti to that in Ecuador?
Offer a terse response. 0.04. What is the ratio of the Emissions(kt) in 1960 in Dominica to that in Dominican Republic?
Your answer should be compact. 0.01. What is the ratio of the Emissions(kt) in 1961 in Dominica to that in Dominican Republic?
Keep it short and to the point. 0.01. What is the ratio of the Emissions(kt) in 1962 in Dominica to that in Dominican Republic?
Make the answer very short. 0.01. What is the ratio of the Emissions(kt) in 1963 in Dominica to that in Dominican Republic?
Offer a very short reply. 0.01. What is the ratio of the Emissions(kt) in 1960 in Dominica to that in Ecuador?
Offer a very short reply. 0.01. What is the ratio of the Emissions(kt) of 1961 in Dominica to that in Ecuador?
Provide a succinct answer. 0.01. What is the ratio of the Emissions(kt) of 1962 in Dominica to that in Ecuador?
Give a very brief answer. 0.01. What is the ratio of the Emissions(kt) in 1963 in Dominica to that in Ecuador?
Provide a succinct answer. 0.01. What is the ratio of the Emissions(kt) of 1960 in Dominican Republic to that in Ecuador?
Ensure brevity in your answer.  0.59. What is the ratio of the Emissions(kt) in 1961 in Dominican Republic to that in Ecuador?
Provide a succinct answer. 0.63. What is the ratio of the Emissions(kt) of 1962 in Dominican Republic to that in Ecuador?
Your response must be concise. 0.79. What is the ratio of the Emissions(kt) of 1963 in Dominican Republic to that in Ecuador?
Your response must be concise. 0.7. What is the difference between the highest and the second highest Emissions(kt) in 1960?
Make the answer very short. 2.80e+04. What is the difference between the highest and the second highest Emissions(kt) of 1961?
Your answer should be very brief. 3.01e+04. What is the difference between the highest and the second highest Emissions(kt) in 1962?
Give a very brief answer. 3.54e+04. What is the difference between the highest and the second highest Emissions(kt) of 1963?
Offer a very short reply. 3.89e+04. What is the difference between the highest and the lowest Emissions(kt) in 1960?
Your answer should be very brief. 2.98e+04. What is the difference between the highest and the lowest Emissions(kt) of 1961?
Make the answer very short. 3.17e+04. What is the difference between the highest and the lowest Emissions(kt) of 1962?
Keep it short and to the point. 3.69e+04. What is the difference between the highest and the lowest Emissions(kt) of 1963?
Your answer should be compact. 4.07e+04. 